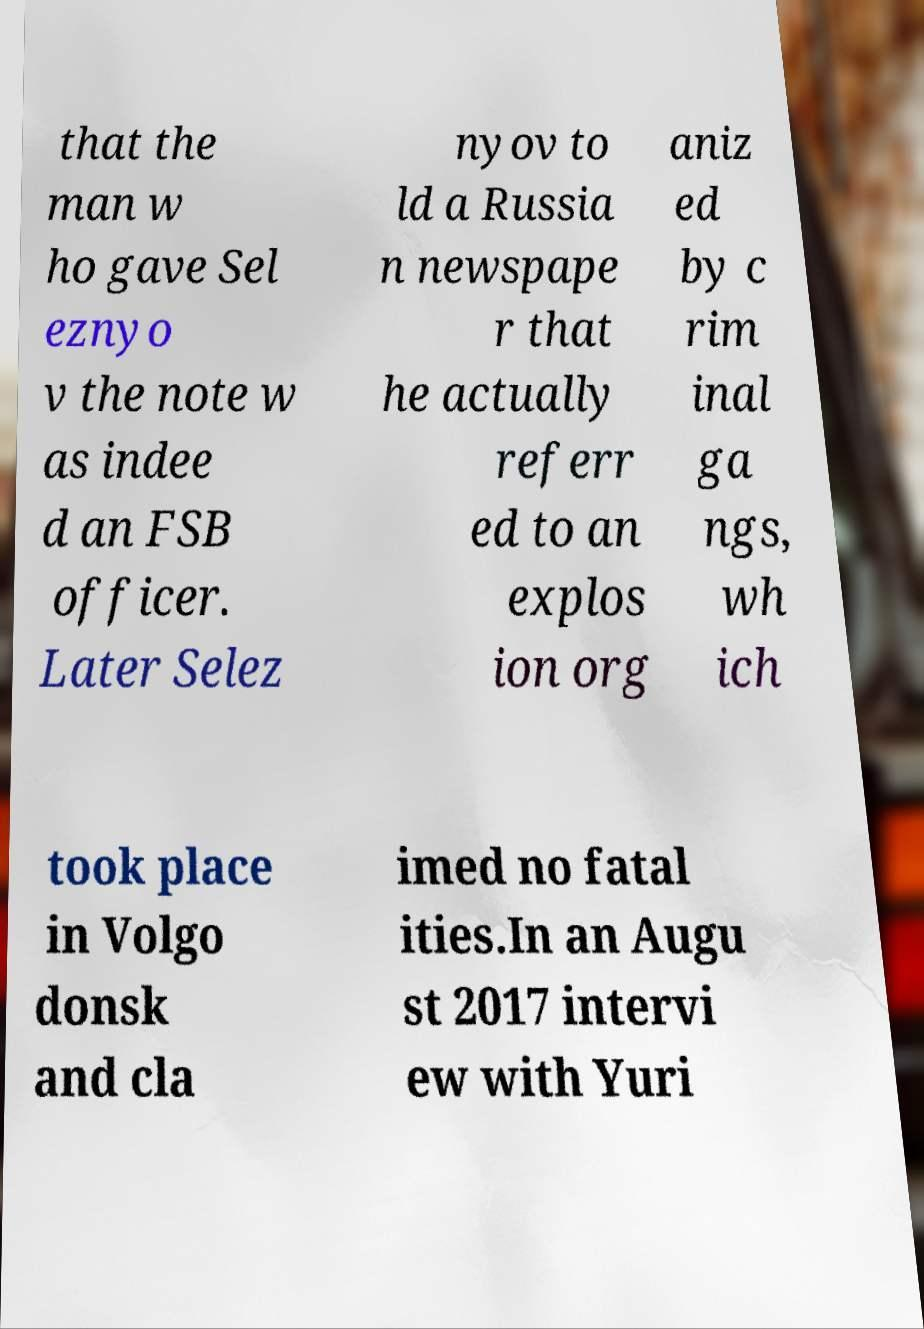There's text embedded in this image that I need extracted. Can you transcribe it verbatim? that the man w ho gave Sel eznyo v the note w as indee d an FSB officer. Later Selez nyov to ld a Russia n newspape r that he actually referr ed to an explos ion org aniz ed by c rim inal ga ngs, wh ich took place in Volgo donsk and cla imed no fatal ities.In an Augu st 2017 intervi ew with Yuri 